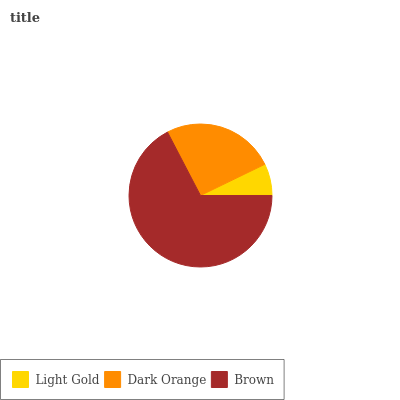Is Light Gold the minimum?
Answer yes or no. Yes. Is Brown the maximum?
Answer yes or no. Yes. Is Dark Orange the minimum?
Answer yes or no. No. Is Dark Orange the maximum?
Answer yes or no. No. Is Dark Orange greater than Light Gold?
Answer yes or no. Yes. Is Light Gold less than Dark Orange?
Answer yes or no. Yes. Is Light Gold greater than Dark Orange?
Answer yes or no. No. Is Dark Orange less than Light Gold?
Answer yes or no. No. Is Dark Orange the high median?
Answer yes or no. Yes. Is Dark Orange the low median?
Answer yes or no. Yes. Is Brown the high median?
Answer yes or no. No. Is Light Gold the low median?
Answer yes or no. No. 